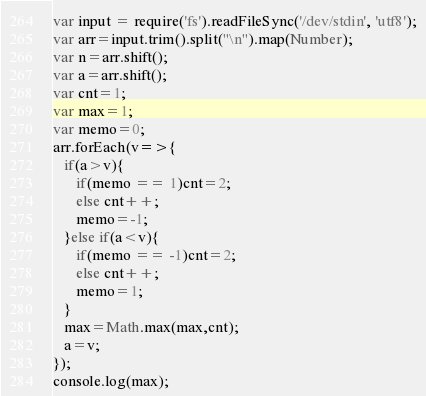Convert code to text. <code><loc_0><loc_0><loc_500><loc_500><_JavaScript_>var input = require('fs').readFileSync('/dev/stdin', 'utf8');
var arr=input.trim().split("\n").map(Number);
var n=arr.shift();
var a=arr.shift();
var cnt=1;
var max=1;
var memo=0;
arr.forEach(v=>{
   if(a>v){
      if(memo == 1)cnt=2;
      else cnt++;
      memo=-1;
   }else if(a<v){
      if(memo == -1)cnt=2;
      else cnt++;      
      memo=1;
   }
   max=Math.max(max,cnt);
   a=v;
});
console.log(max);
</code> 